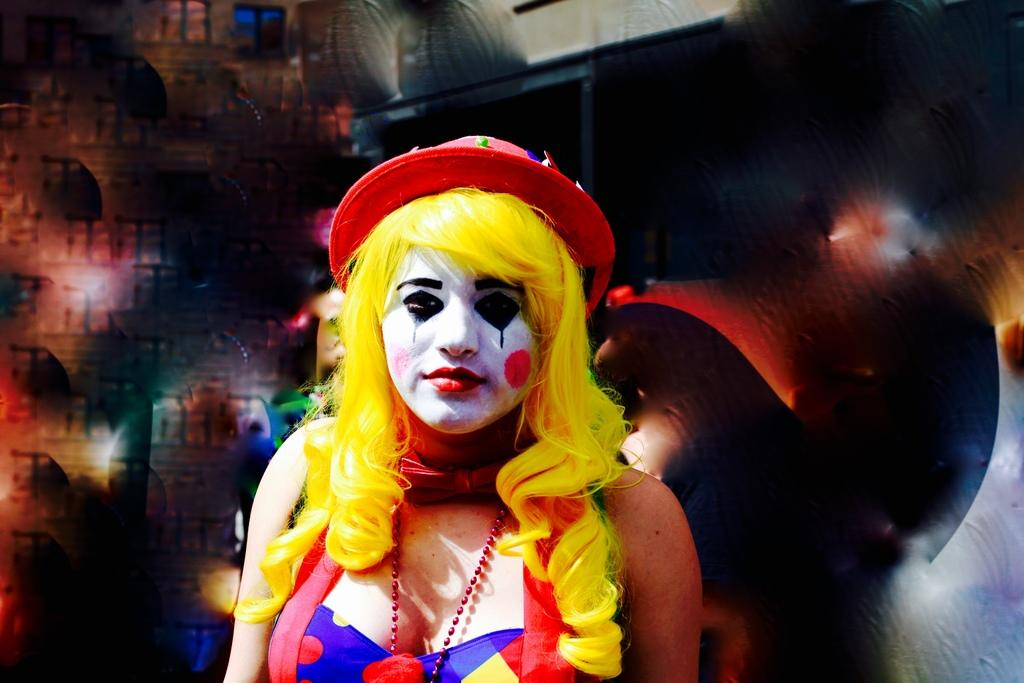What can be observed about the background of the image? The background portion of the picture is blurred and messy. Can you describe the woman in the image? There is a woman in the image, and she is wearing a hat and a wig. What is unique about the woman's appearance? There is a painting on the woman's face. What type of toothpaste is being used to create the painting on the woman's face? There is no toothpaste present in the image, and the painting on the woman's face is not created using toothpaste. 